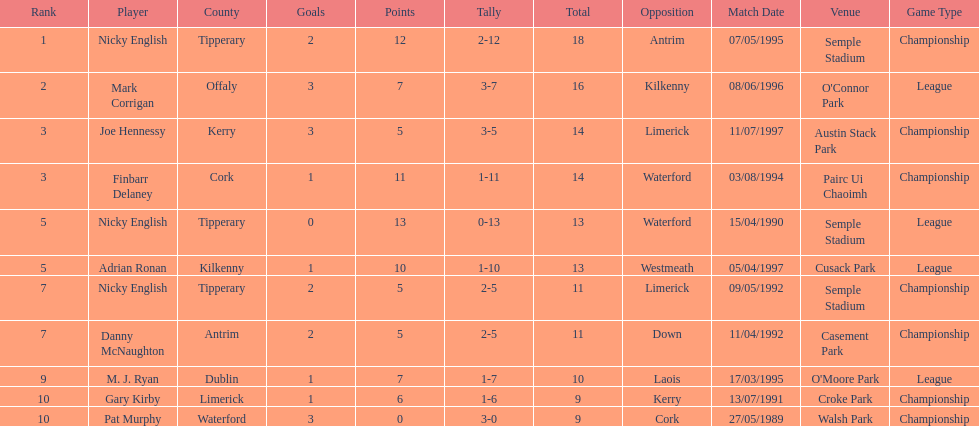What is the smallest sum in the list? 9. Could you help me parse every detail presented in this table? {'header': ['Rank', 'Player', 'County', 'Goals', 'Points', 'Tally', 'Total', 'Opposition', 'Match Date', 'Venue', 'Game Type'], 'rows': [['1', 'Nicky English', 'Tipperary', '2', '12', '2-12', '18', 'Antrim', '07/05/1995', 'Semple Stadium', 'Championship'], ['2', 'Mark Corrigan', 'Offaly', '3', '7', '3-7', '16', 'Kilkenny', '08/06/1996', "O'Connor Park", 'League'], ['3', 'Joe Hennessy', 'Kerry', '3', '5', '3-5', '14', 'Limerick', '11/07/1997', 'Austin Stack Park', 'Championship'], ['3', 'Finbarr Delaney', 'Cork', '1', '11', '1-11', '14', 'Waterford', '03/08/1994', 'Pairc Ui Chaoimh', 'Championship'], ['5', 'Nicky English', 'Tipperary', '0', '13', '0-13', '13', 'Waterford', '15/04/1990', 'Semple Stadium', 'League'], ['5', 'Adrian Ronan', 'Kilkenny', '1', '10', '1-10', '13', 'Westmeath', '05/04/1997', 'Cusack Park', 'League'], ['7', 'Nicky English', 'Tipperary', '2', '5', '2-5', '11', 'Limerick', '09/05/1992', 'Semple Stadium', 'Championship'], ['7', 'Danny McNaughton', 'Antrim', '2', '5', '2-5', '11', 'Down', '11/04/1992', 'Casement Park', 'Championship'], ['9', 'M. J. Ryan', 'Dublin', '1', '7', '1-7', '10', 'Laois', '17/03/1995', "O'Moore Park", 'League'], ['10', 'Gary Kirby', 'Limerick', '1', '6', '1-6', '9', 'Kerry', '13/07/1991', 'Croke Park', 'Championship'], ['10', 'Pat Murphy', 'Waterford', '3', '0', '3-0', '9', 'Cork', '27/05/1989', 'Walsh Park', 'Championship']]} 